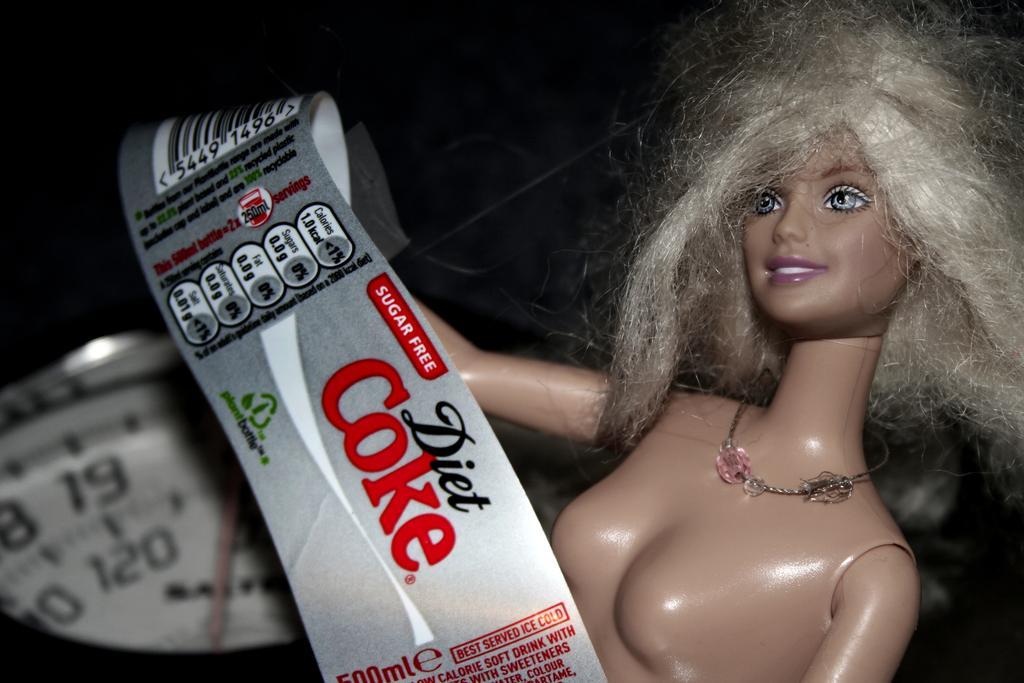In one or two sentences, can you explain what this image depicts? In this picture we can see a doll, a label and it looks like a weighing scale object. Behind the doll where is the dark background. 